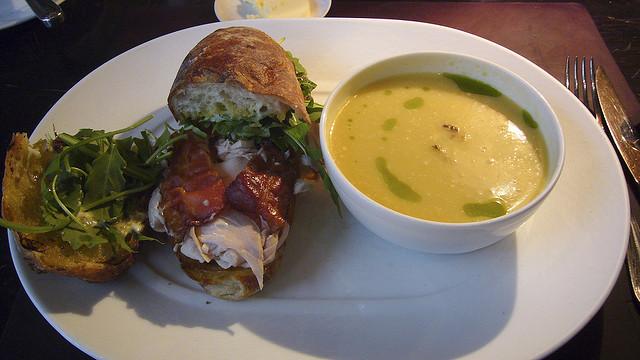What is the green vegetable?
Keep it brief. Lettuce. Are the rolls toasted?
Short answer required. Yes. Is there a steak filet on the plate?
Concise answer only. No. What is the small bowel?
Write a very short answer. Soup. What is that green stuff?
Be succinct. Lettuce. What is the meat on the sandwich?
Give a very brief answer. Turkey. 